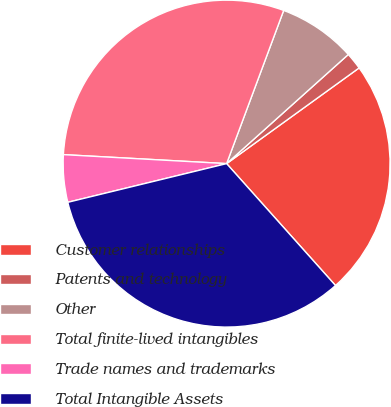Convert chart. <chart><loc_0><loc_0><loc_500><loc_500><pie_chart><fcel>Customer relationships<fcel>Patents and technology<fcel>Other<fcel>Total finite-lived intangibles<fcel>Trade names and trademarks<fcel>Total Intangible Assets<nl><fcel>23.35%<fcel>1.68%<fcel>7.69%<fcel>29.8%<fcel>4.68%<fcel>32.8%<nl></chart> 